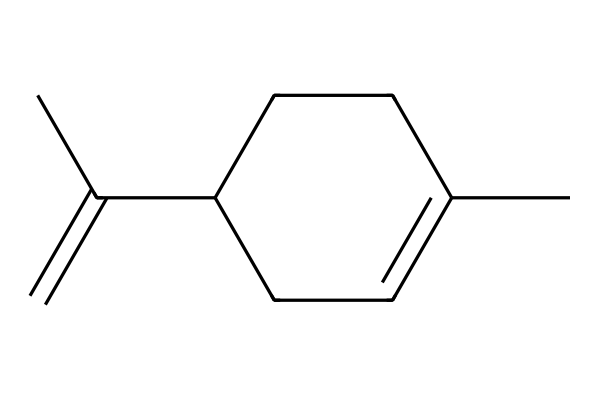What is the molecular formula of limonene? To determine the molecular formula, we can count the number of each type of atom in the SMILES representation. Limonene has 10 carbon (C) atoms and 16 hydrogen (H) atoms, leading to the formula C10H16.
Answer: C10H16 How many rings are present in limonene? By analyzing the structure provided in the SMILES, we note that there are no numerical indicators (e.g., numbers) indicating ring closures, thus implying that limonene is acyclic and consists of 0 rings.
Answer: 0 What type of hydrocarbon is limonene? Limonene contains a double bond in its structure, which categorizes it as an alkene. Since it is a cyclic compound with unsaturation, it is classified as a monoterpene.
Answer: monoterpene How many double bonds are present in limonene? In the SMILES, the presence of "C(=C)" indicates one double bond between two carbon atoms. By examining the entire structure, we confirm there is only one double bond.
Answer: 1 What is the main functional group in limonene? Analyzing the structure, limonene primarily exhibits features of alkenes but lacks functional groups such as alcohols or ketones. Therefore, the predominant feature is the alkene functional group due to the presence of the double bond.
Answer: alkene What is the significance of the structure of limonene in sustainable cleaning products? Limonene's structure allows it to be an effective natural solvent due to its ability to dissolve oils and greases, providing a biodegradable alternative to synthetic solvents in cleaning products.
Answer: natural solvent 